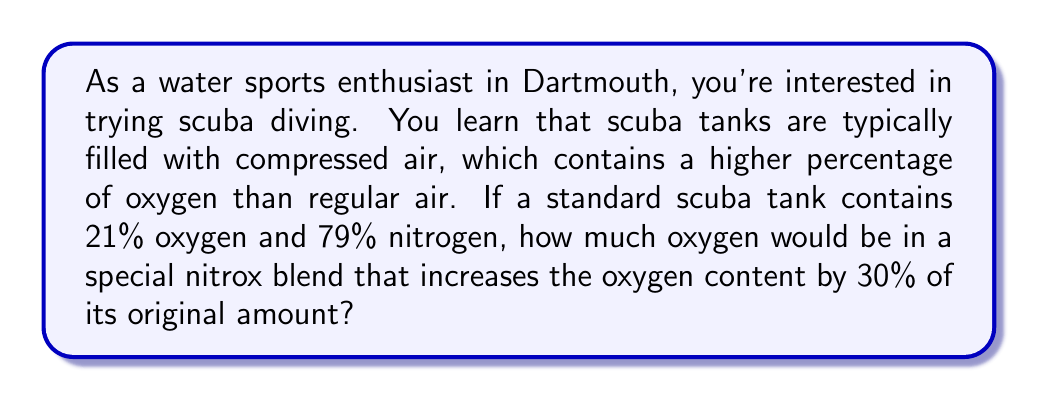Teach me how to tackle this problem. Let's approach this step-by-step:

1. First, we need to understand the initial composition:
   Regular air in scuba tanks: 21% oxygen, 79% nitrogen

2. We're told that the oxygen content is increased by 30% of its original amount. To calculate this:
   $$ \text{Increase in oxygen} = 21\% \times 30\% = 21\% \times 0.30 = 6.3\% $$

3. Now, we add this increase to the original oxygen percentage:
   $$ \text{New oxygen percentage} = 21\% + 6.3\% = 27.3\% $$

4. To verify our calculation, we can check if the percentages still add up to 100%:
   Oxygen: 27.3%
   Nitrogen: 72.7% (100% - 27.3%)
   $$ 27.3\% + 72.7\% = 100\% $$

Therefore, the special nitrox blend would contain 27.3% oxygen.
Answer: 27.3% oxygen 